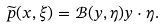Convert formula to latex. <formula><loc_0><loc_0><loc_500><loc_500>\widetilde { p } ( x , \xi ) = { \mathcal { B } } ( y , \eta ) y \cdot \eta .</formula> 